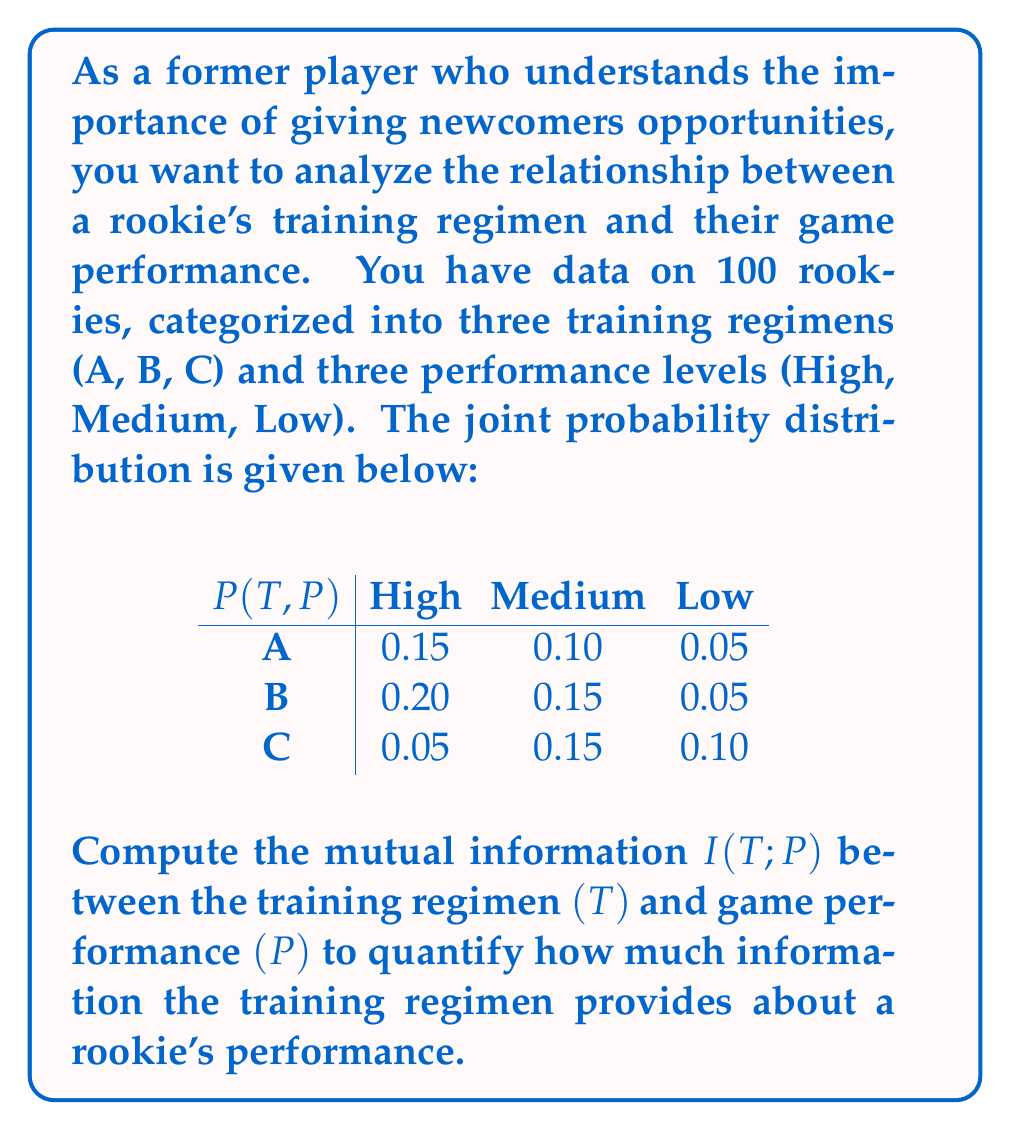Could you help me with this problem? To compute the mutual information $I(T;P)$, we'll follow these steps:

1) First, we need to calculate the marginal probabilities $P(T)$ and $P(P)$:

   $P(T=A) = 0.15 + 0.10 + 0.05 = 0.30$
   $P(T=B) = 0.20 + 0.15 + 0.05 = 0.40$
   $P(T=C) = 0.05 + 0.15 + 0.10 = 0.30$

   $P(P=\text{High}) = 0.15 + 0.20 + 0.05 = 0.40$
   $P(P=\text{Medium}) = 0.10 + 0.15 + 0.15 = 0.40$
   $P(P=\text{Low}) = 0.05 + 0.05 + 0.10 = 0.20$

2) The formula for mutual information is:

   $$I(T;P) = \sum_{t \in T} \sum_{p \in P} P(t,p) \log_2 \frac{P(t,p)}{P(t)P(p)}$$

3) Now, we calculate each term:

   $0.15 \log_2 \frac{0.15}{0.30 \cdot 0.40} = 0.15 \log_2 1.25 = 0.0361$
   $0.10 \log_2 \frac{0.10}{0.30 \cdot 0.40} = 0.10 \log_2 0.8333 = -0.0231$
   $0.05 \log_2 \frac{0.05}{0.30 \cdot 0.20} = 0.05 \log_2 0.8333 = -0.0116$
   $0.20 \log_2 \frac{0.20}{0.40 \cdot 0.40} = 0.20 \log_2 1.25 = 0.0482$
   $0.15 \log_2 \frac{0.15}{0.40 \cdot 0.40} = 0.15 \log_2 0.9375 = -0.0140$
   $0.05 \log_2 \frac{0.05}{0.40 \cdot 0.20} = 0.05 \log_2 0.625 = -0.0344$
   $0.05 \log_2 \frac{0.05}{0.30 \cdot 0.40} = 0.05 \log_2 0.4167 = -0.0631$
   $0.15 \log_2 \frac{0.15}{0.30 \cdot 0.40} = 0.15 \log_2 1.25 = 0.0361$
   $0.10 \log_2 \frac{0.10}{0.30 \cdot 0.20} = 0.10 \log_2 1.6667 = 0.0736$

4) Sum all these terms:

   $I(T;P) = 0.0361 - 0.0231 - 0.0116 + 0.0482 - 0.0140 - 0.0344 - 0.0631 + 0.0361 + 0.0736 = 0.0478$

Therefore, the mutual information $I(T;P)$ is approximately 0.0478 bits.
Answer: $I(T;P) \approx 0.0478$ bits 